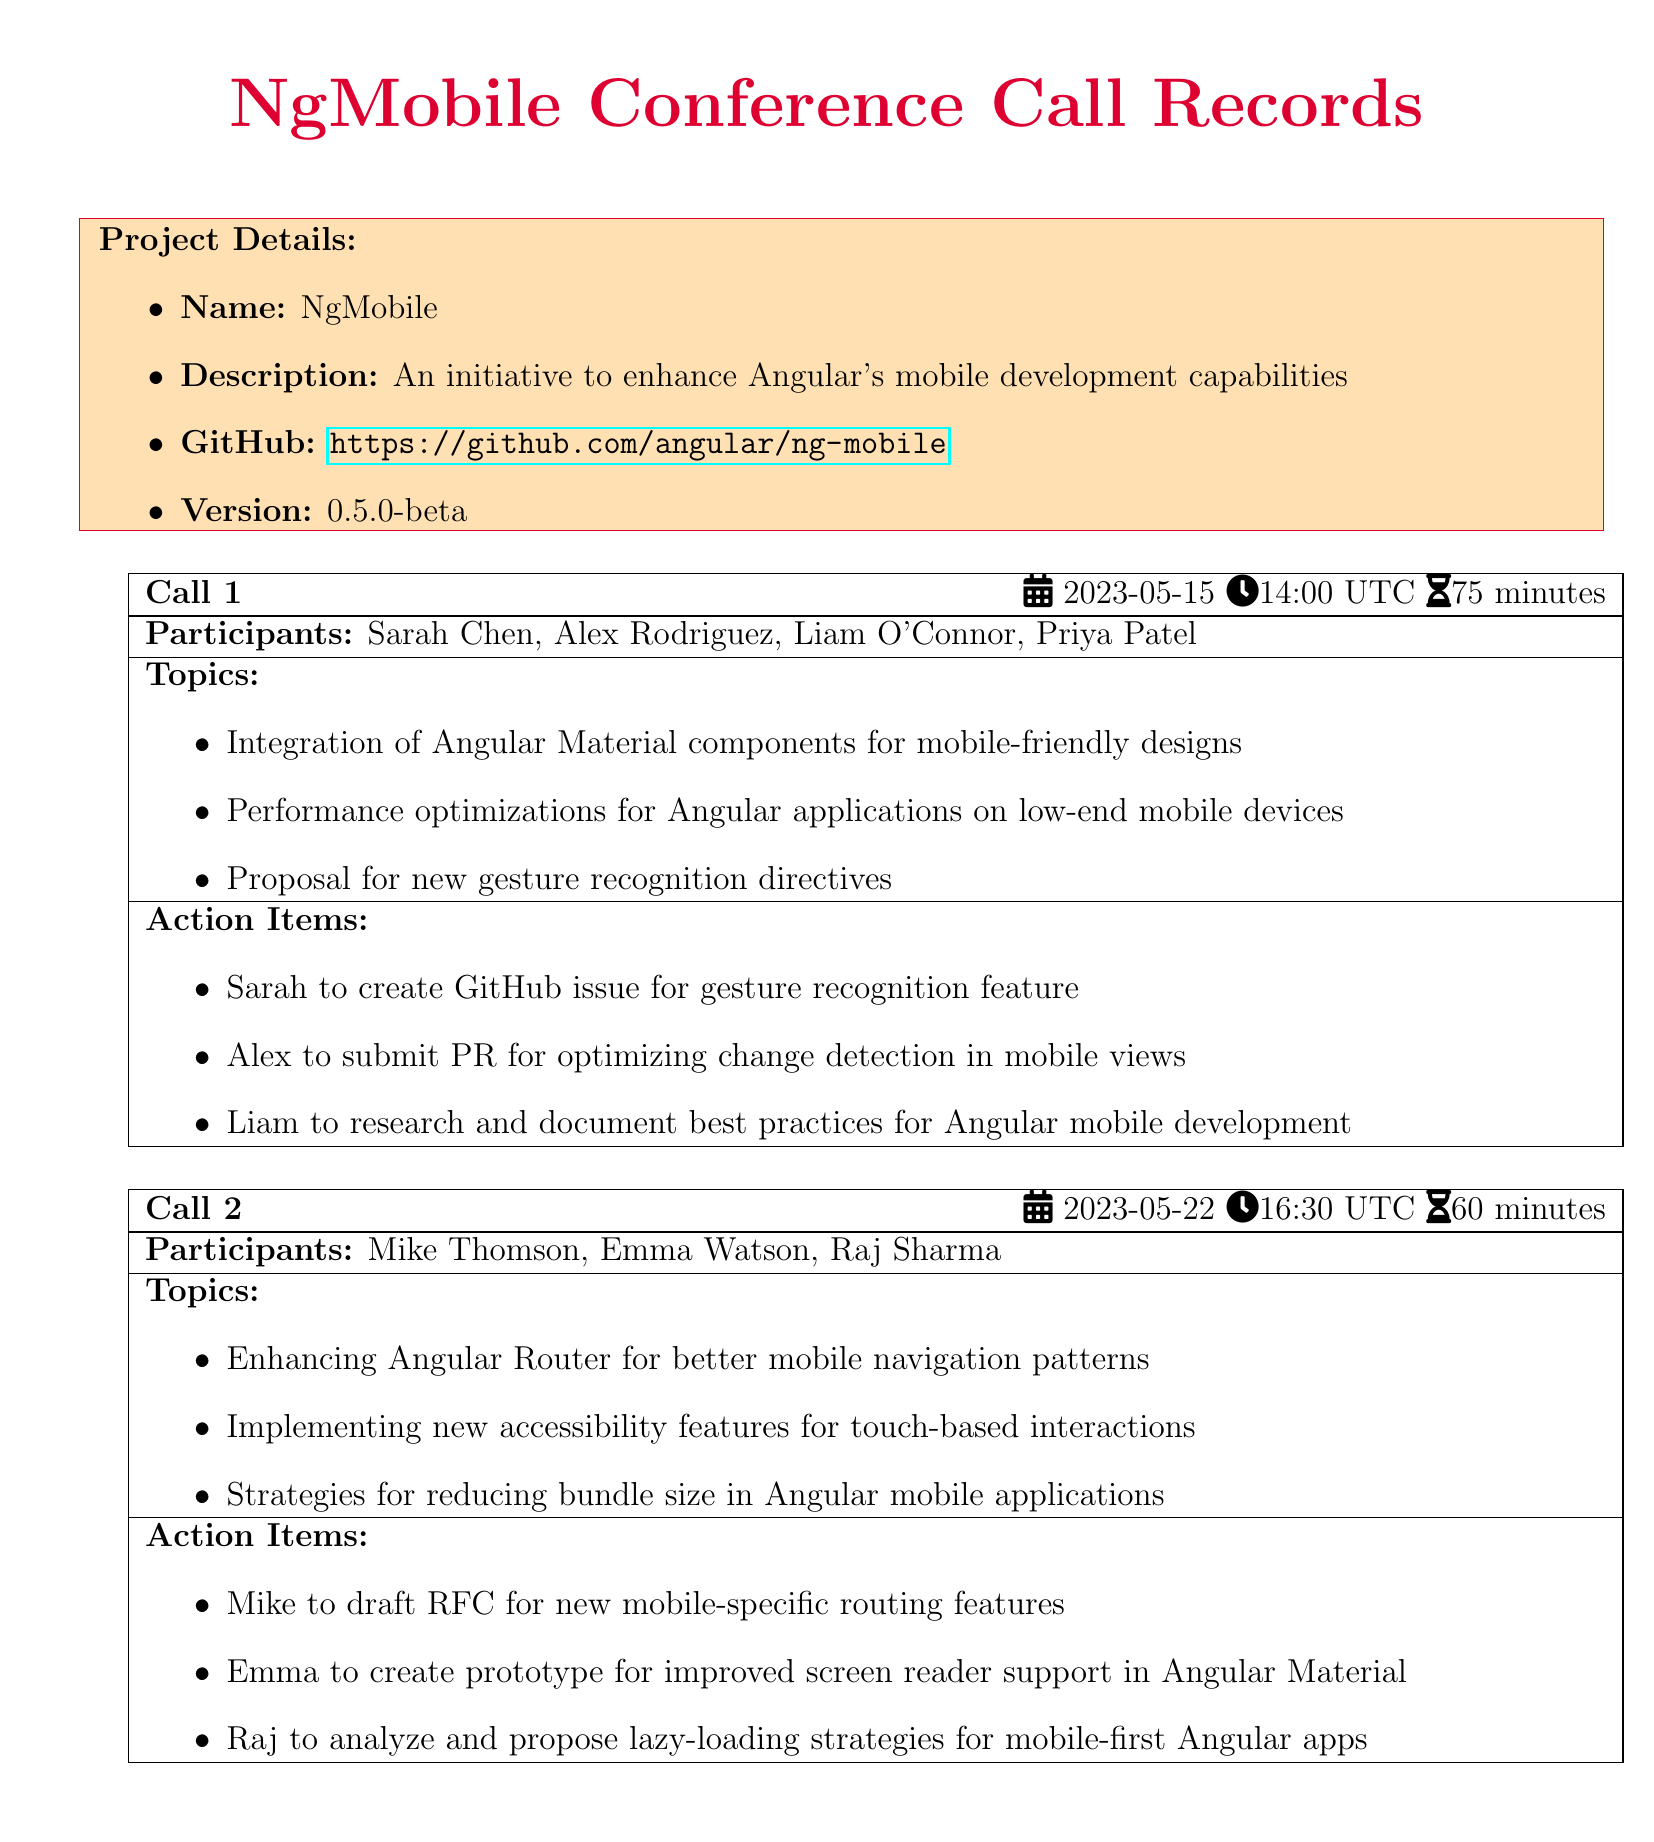What is the project name? The project name is listed in the project details section of the document.
Answer: NgMobile When did the first conference call take place? The date of the first conference call is provided at the beginning of Call 1.
Answer: 2023-05-15 Who proposed the gesture recognition directives? The action items from Call 1 specify who is responsible for the gesture recognition feature.
Answer: Sarah What is the main focus of Call 2? The topics discussed in Call 2 outline the main focus, which involves multiple improvements for mobile development.
Answer: Enhancing Angular Router How long did the second call last? The duration of Call 2 is specified in the call overview section.
Answer: 60 minutes Who is responsible for creating a prototype for screen reader support? The action items in Call 2 indicate who will create the prototype.
Answer: Emma What version is the project currently at? The project version is listed in the project details section of the document.
Answer: 0.5.0-beta Which participant is tasked with researching best practices? The action items from Call 1 outline who will research best practices for mobile development.
Answer: Liam What is the goal of the NgMobile initiative? The project description defines the main goal of the NgMobile initiative.
Answer: Enhance Angular's mobile development capabilities 